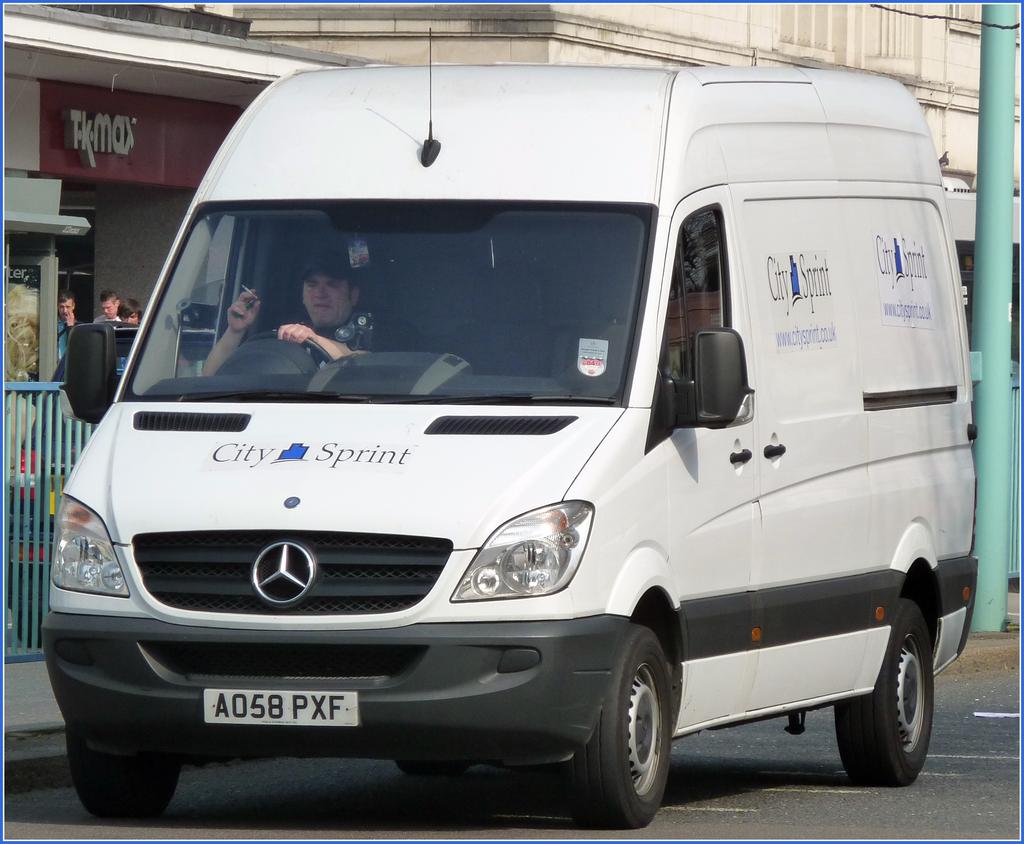What is the second word, next to city, on the van?
Make the answer very short. Sprint. What comapny name is on the hood of this van?
Provide a succinct answer. City sprint. 